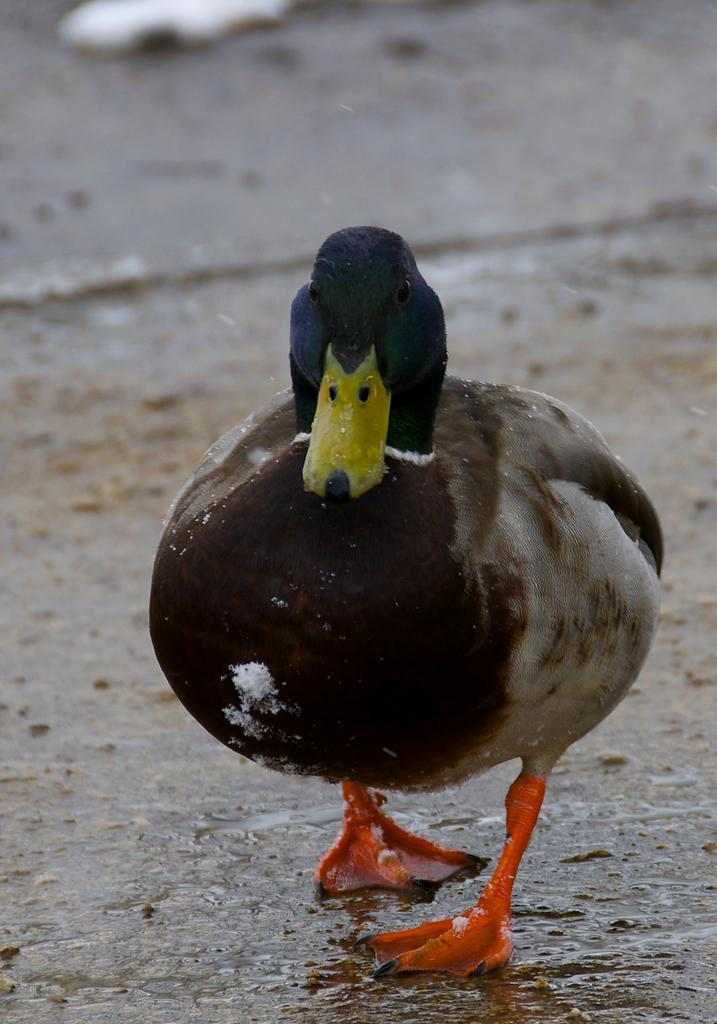What type of animal is present in the image? There is a duck in the image. What is the duck doing in the image? The duck is standing on the ground. What type of motion is the duck performing in the image? The duck is not performing any motion in the image; it is standing still on the ground. Is the duck depicted as a fireman in the image? No, the duck is not depicted as a fireman in the image; it is simply a duck standing on the ground. 